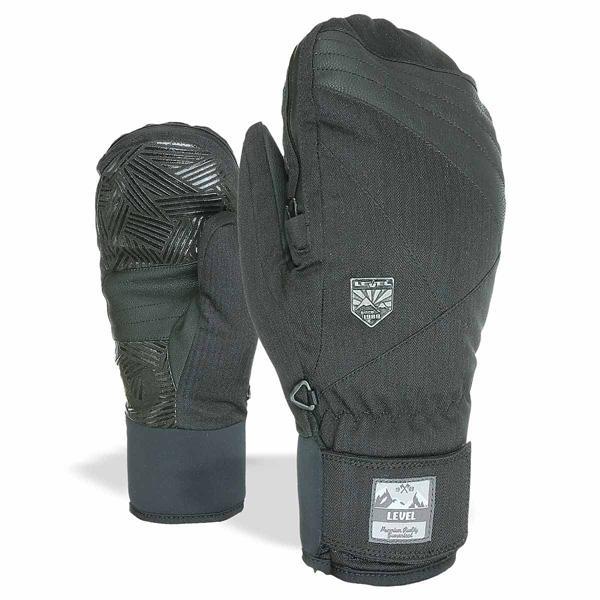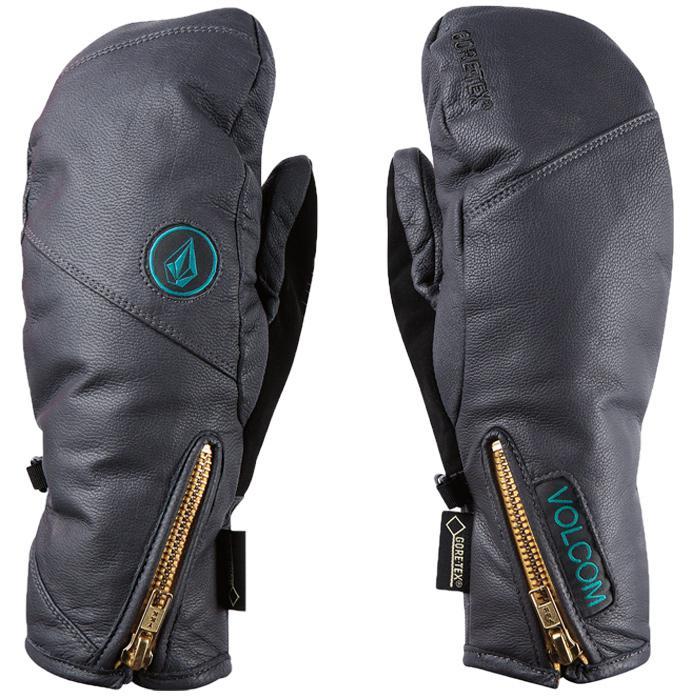The first image is the image on the left, the second image is the image on the right. Considering the images on both sides, is "A glove with individual fingers is visible." valid? Answer yes or no. No. The first image is the image on the left, the second image is the image on the right. Given the left and right images, does the statement "One image shows a matched pair of mittens, and the other image includes a glove with fingers." hold true? Answer yes or no. No. 